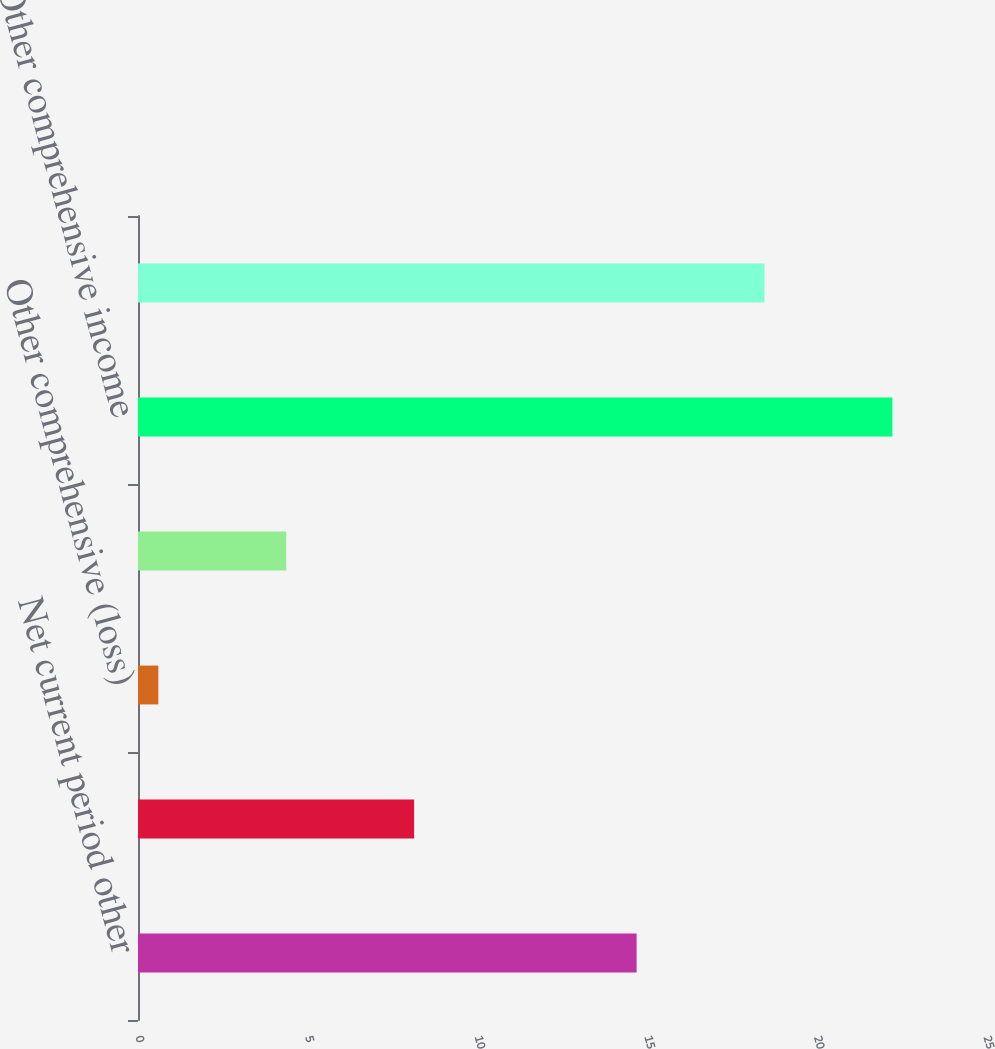<chart> <loc_0><loc_0><loc_500><loc_500><bar_chart><fcel>Net current period other<fcel>Balance as of December 31 2016<fcel>Other comprehensive (loss)<fcel>Balance as of December 31 2017<fcel>Other comprehensive income<fcel>Balance as of December 31 2018<nl><fcel>14.7<fcel>8.14<fcel>0.6<fcel>4.37<fcel>22.24<fcel>18.47<nl></chart> 